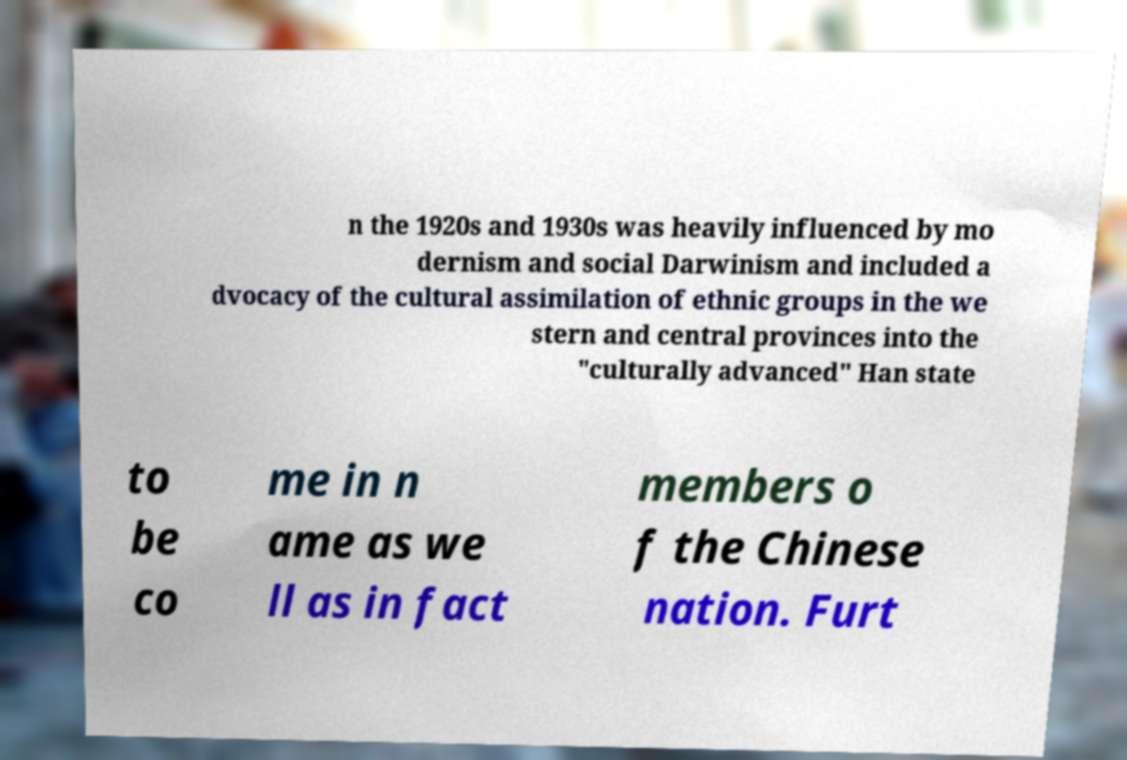There's text embedded in this image that I need extracted. Can you transcribe it verbatim? n the 1920s and 1930s was heavily influenced by mo dernism and social Darwinism and included a dvocacy of the cultural assimilation of ethnic groups in the we stern and central provinces into the "culturally advanced" Han state to be co me in n ame as we ll as in fact members o f the Chinese nation. Furt 